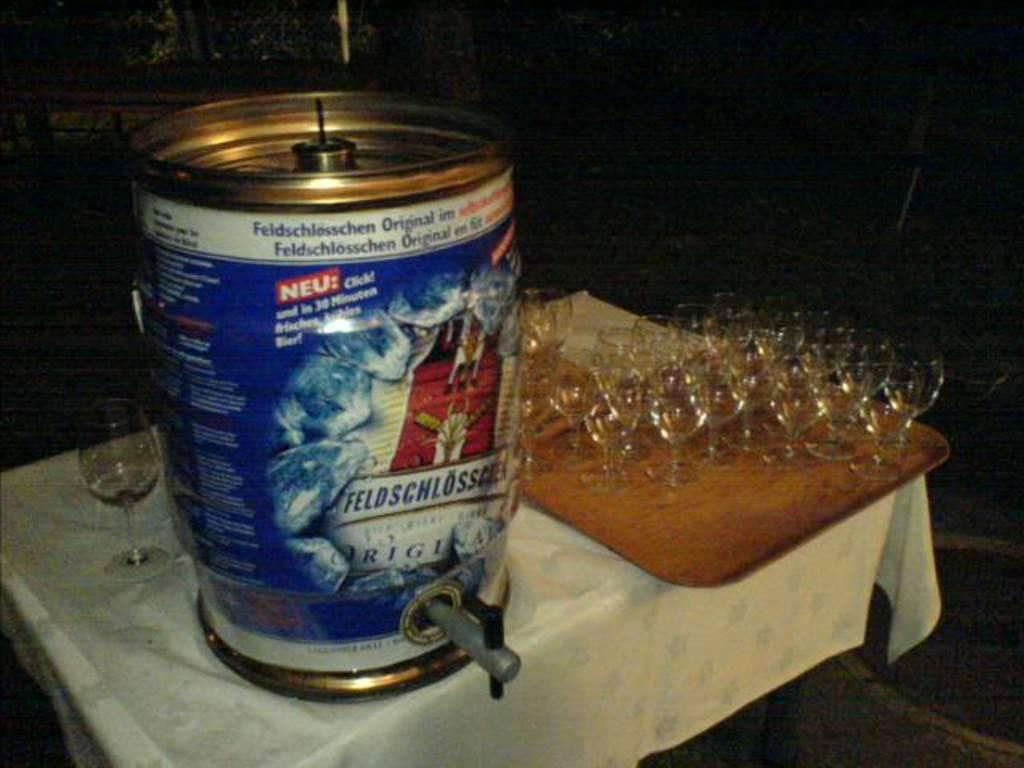Provide a one-sentence caption for the provided image. Several wine glasses arearranged on a wooden tray with a Keg with the label for Feldschlosser on it. 